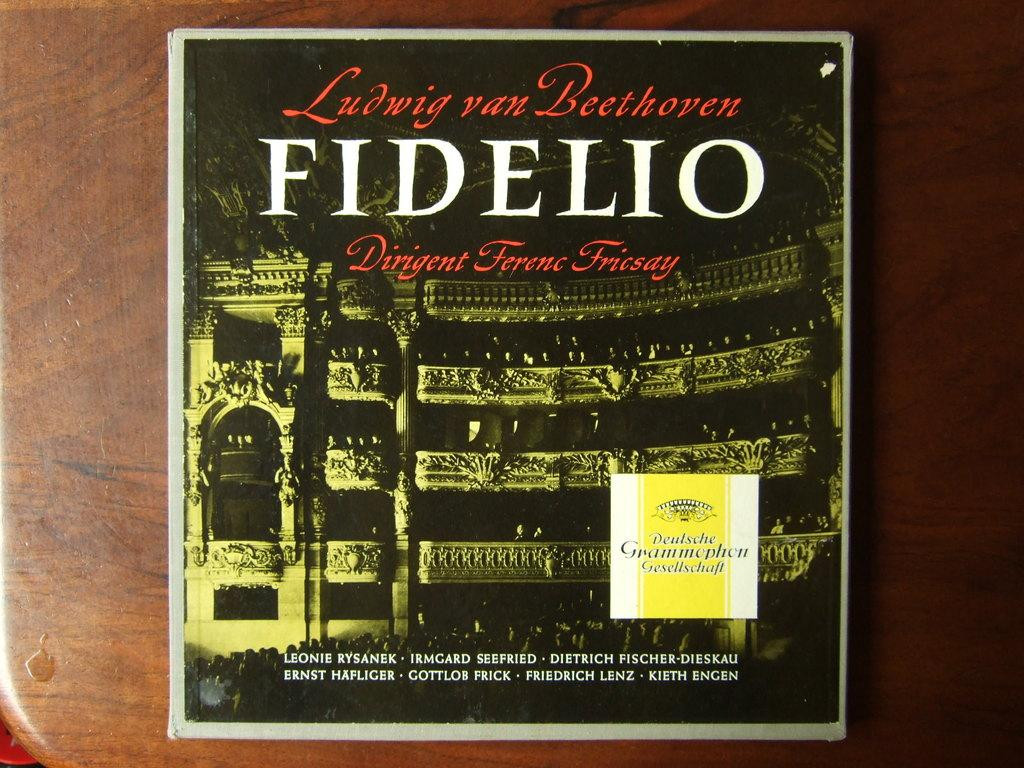<image>
Give a short and clear explanation of the subsequent image. Album cover with the word "FIDELIO" in white letters. 